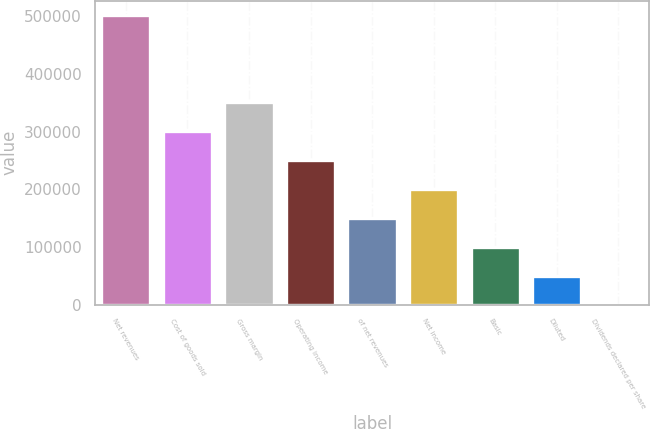<chart> <loc_0><loc_0><loc_500><loc_500><bar_chart><fcel>Net revenues<fcel>Cost of goods sold<fcel>Gross margin<fcel>Operating income<fcel>of net revenues<fcel>Net income<fcel>Basic<fcel>Diluted<fcel>Dividends declared per share<nl><fcel>501267<fcel>300760<fcel>350887<fcel>250634<fcel>150380<fcel>200507<fcel>100254<fcel>50126.9<fcel>0.19<nl></chart> 